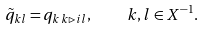<formula> <loc_0><loc_0><loc_500><loc_500>\tilde { q } _ { k l } = q _ { k \, k \rhd i l } , \quad k , l \in X ^ { - 1 } .</formula> 